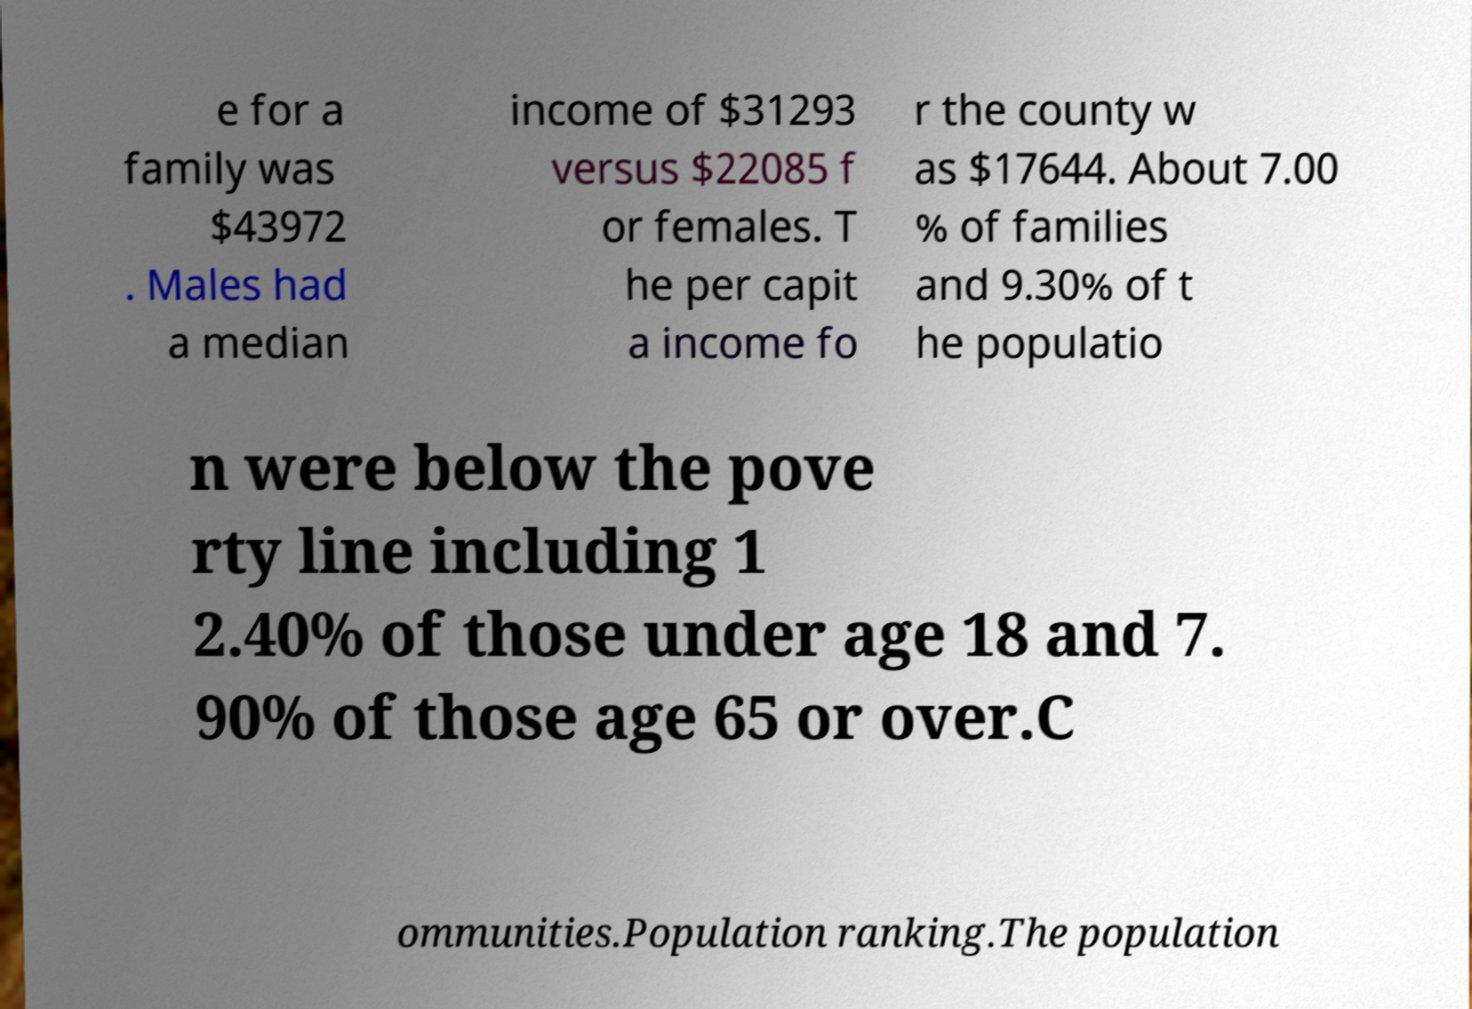What messages or text are displayed in this image? I need them in a readable, typed format. e for a family was $43972 . Males had a median income of $31293 versus $22085 f or females. T he per capit a income fo r the county w as $17644. About 7.00 % of families and 9.30% of t he populatio n were below the pove rty line including 1 2.40% of those under age 18 and 7. 90% of those age 65 or over.C ommunities.Population ranking.The population 